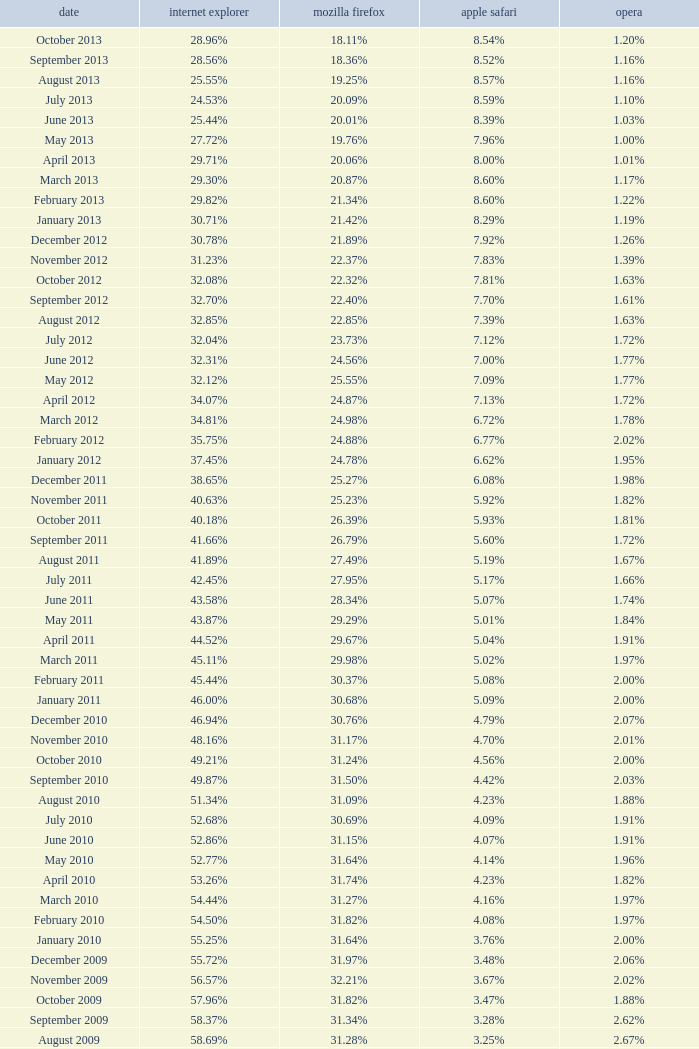What percentage of browsers were using Opera in November 2009? 2.02%. 